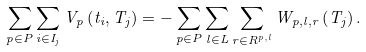<formula> <loc_0><loc_0><loc_500><loc_500>\sum _ { p \in P } \sum _ { i \in I _ { j } } V _ { p } \left ( t _ { i } , T _ { j } \right ) = - \sum _ { p \in P } \sum _ { l \in L } \sum _ { r \in R ^ { p , l } } W _ { p , l , r } \left ( T _ { j } \right ) .</formula> 